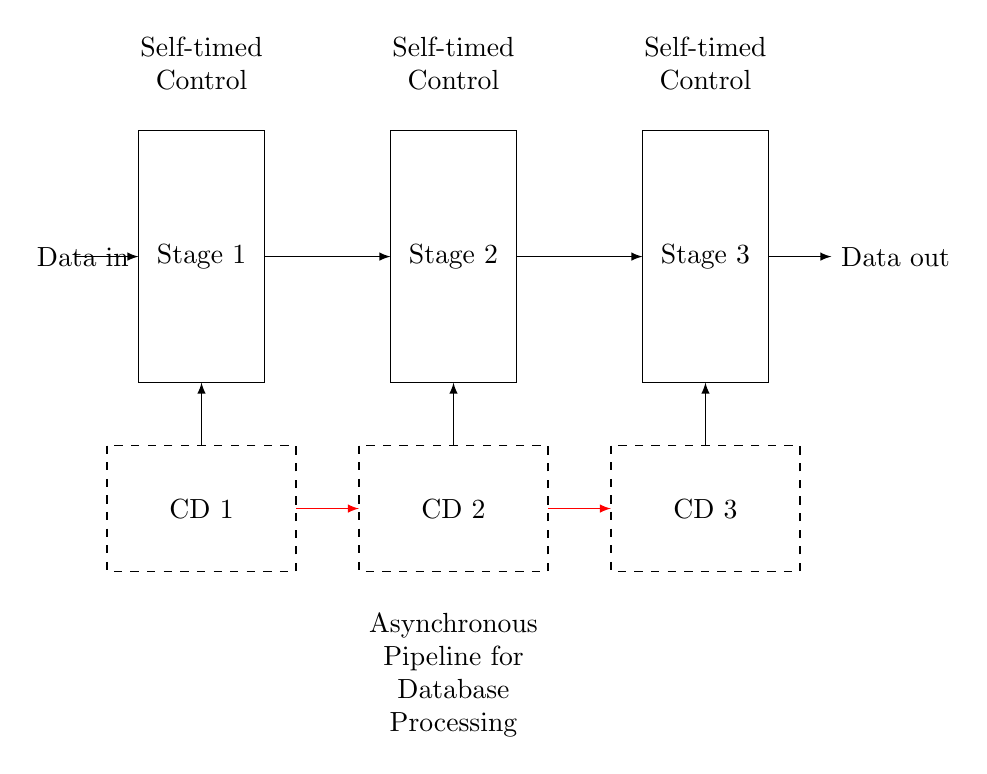What are the stages in this pipeline? The circuit diagram shows three stages labeled Stage 1, Stage 2, and Stage 3, indicating that this pipeline has three processing stages.
Answer: Stage 1, Stage 2, Stage 3 What does CD stand for in this circuit? CD stands for Completion Detection, which is indicated in the dashed rectangles below each stage. These units monitor when processing in each stage is complete.
Answer: Completion Detection How many handshake signals are there in the diagram? The diagram includes two handshake signals, represented by red arrows between the stages, which facilitate communication and coordination between them.
Answer: 2 What is the primary function of self-timed control units? The self-timed control units are responsible for managing the operation of each stage based on the completion signals of the previous stage, allowing for asynchronous operation.
Answer: Manage operation What data flows in this pipeline? The data flows from the left side of the diagram into Stage 1, then through Stage 2 and Stage 3, and finally exits from the right side as Data out.
Answer: Data in, Data out How many data processing stages are asynchronous? All three stages are asynchronous, as the design specifies that there are self-timed controls for each stage, indicating they operate independently and concurrently.
Answer: 3 